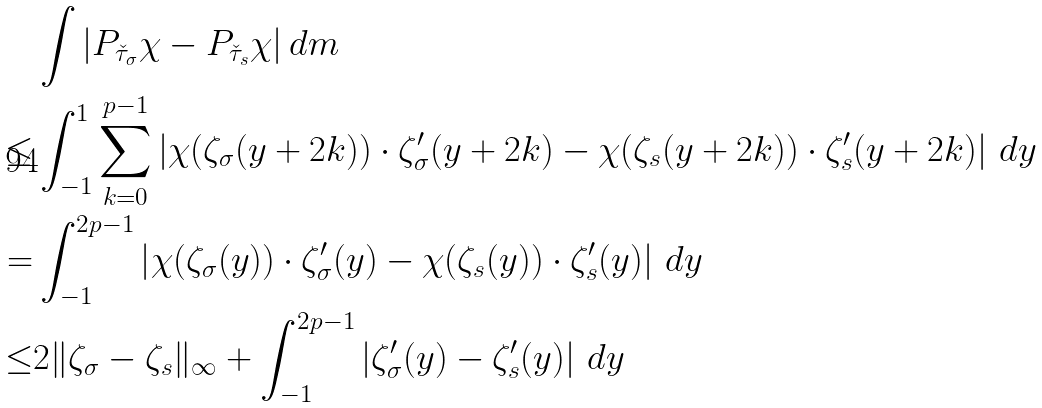Convert formula to latex. <formula><loc_0><loc_0><loc_500><loc_500>& \int | P _ { \check { \tau } _ { \sigma } } \chi - P _ { \check { \tau } _ { s } } \chi | \, d m \\ \leq & \int _ { - 1 } ^ { 1 } \sum _ { k = 0 } ^ { p - 1 } \left | \chi ( \zeta _ { \sigma } ( y + 2 k ) ) \cdot \zeta _ { \sigma } ^ { \prime } ( y + 2 k ) - \chi ( \zeta _ { s } ( y + 2 k ) ) \cdot \zeta _ { s } ^ { \prime } ( y + 2 k ) \right | \, d y \\ = & \int _ { - 1 } ^ { 2 p - 1 } \left | \chi ( \zeta _ { \sigma } ( y ) ) \cdot \zeta _ { \sigma } ^ { \prime } ( y ) - \chi ( \zeta _ { s } ( y ) ) \cdot \zeta _ { s } ^ { \prime } ( y ) \right | \, d y \\ \leq & 2 \| \zeta _ { \sigma } - \zeta _ { s } \| _ { \infty } + \int _ { - 1 } ^ { 2 p - 1 } \left | \zeta _ { \sigma } ^ { \prime } ( y ) - \zeta _ { s } ^ { \prime } ( y ) \right | \, d y</formula> 